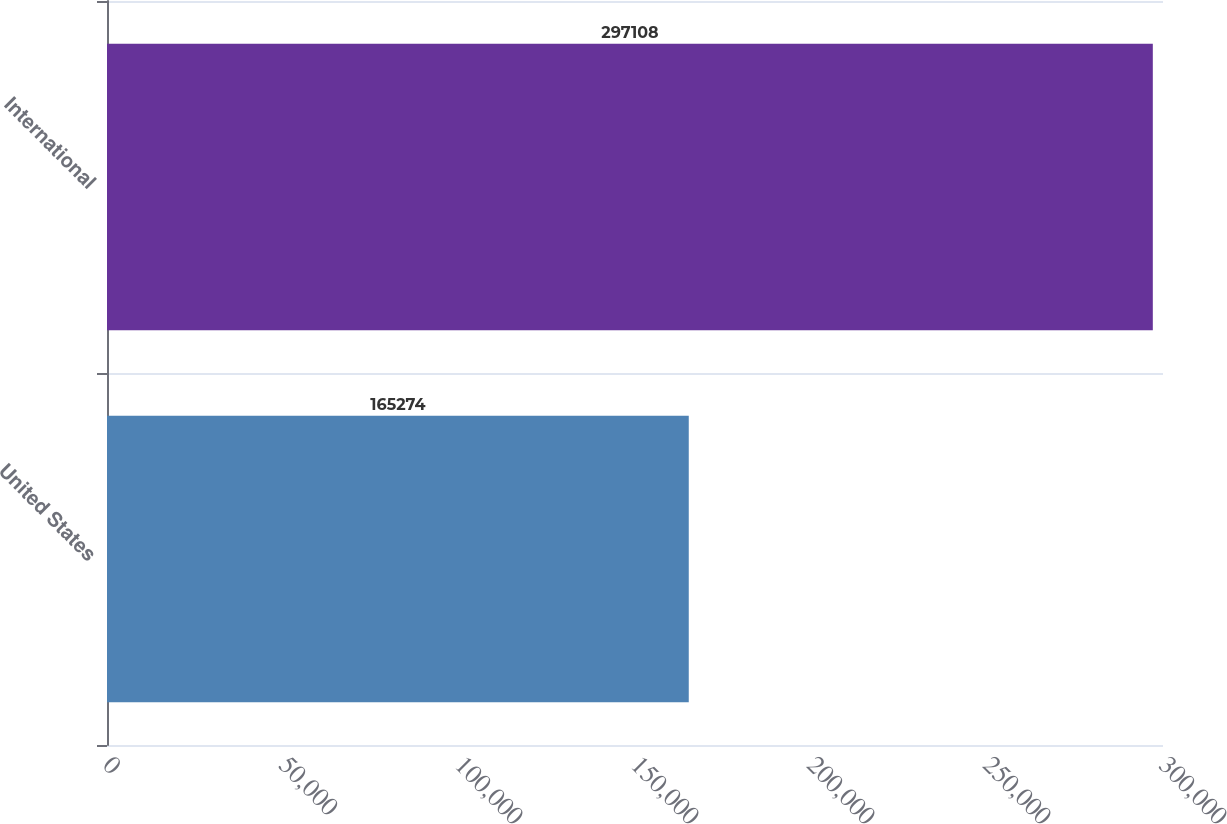Convert chart. <chart><loc_0><loc_0><loc_500><loc_500><bar_chart><fcel>United States<fcel>International<nl><fcel>165274<fcel>297108<nl></chart> 